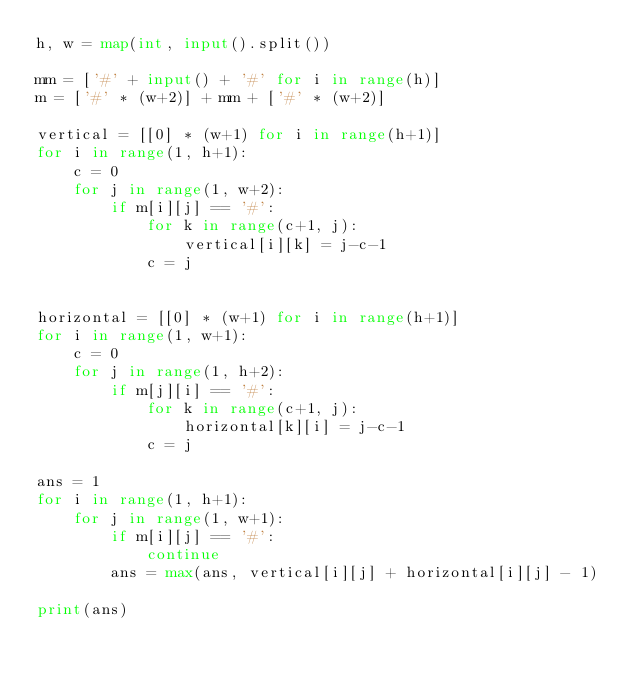Convert code to text. <code><loc_0><loc_0><loc_500><loc_500><_Python_>h, w = map(int, input().split())

mm = ['#' + input() + '#' for i in range(h)]
m = ['#' * (w+2)] + mm + ['#' * (w+2)]

vertical = [[0] * (w+1) for i in range(h+1)]
for i in range(1, h+1):
    c = 0
    for j in range(1, w+2):
        if m[i][j] == '#':
            for k in range(c+1, j):
                vertical[i][k] = j-c-1
            c = j


horizontal = [[0] * (w+1) for i in range(h+1)]
for i in range(1, w+1):
    c = 0
    for j in range(1, h+2):
        if m[j][i] == '#':
            for k in range(c+1, j):
                horizontal[k][i] = j-c-1
            c = j

ans = 1
for i in range(1, h+1):
    for j in range(1, w+1):
        if m[i][j] == '#':
            continue
        ans = max(ans, vertical[i][j] + horizontal[i][j] - 1)

print(ans)
</code> 